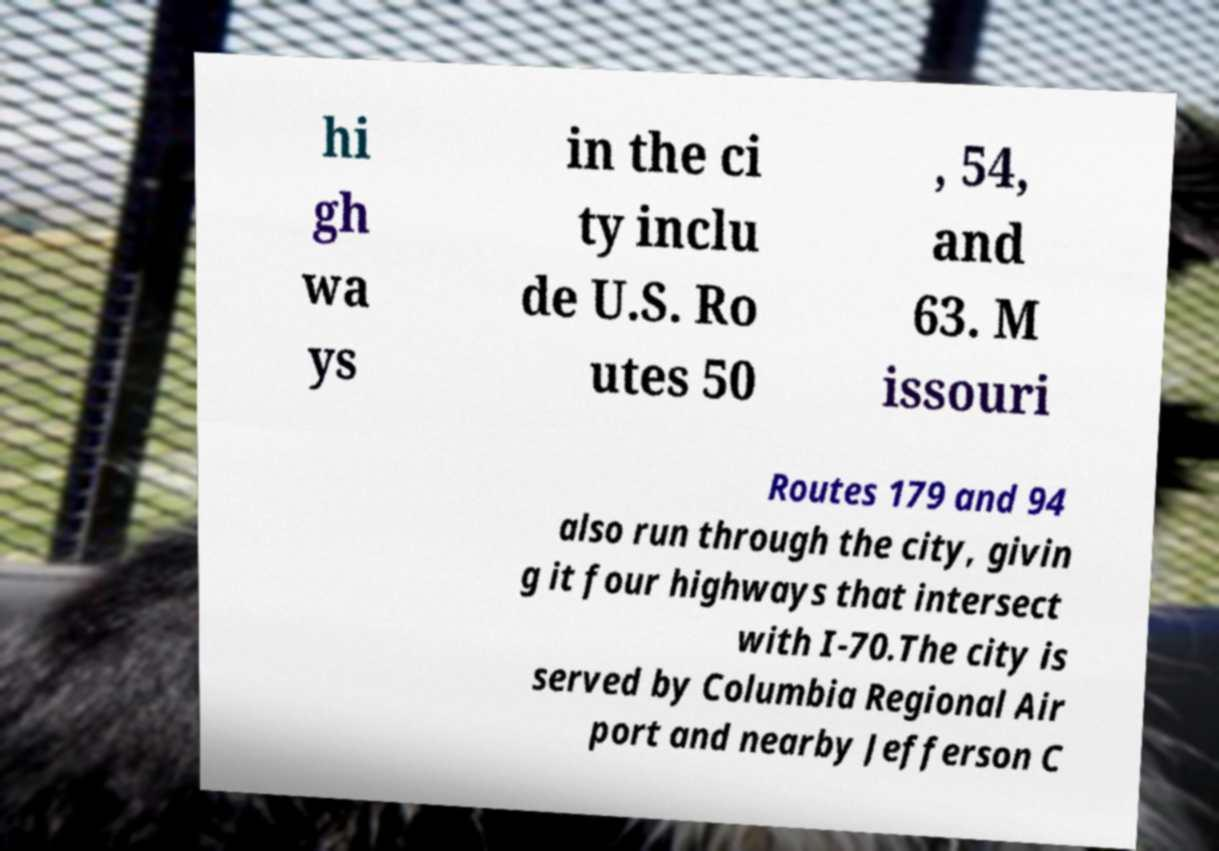Could you assist in decoding the text presented in this image and type it out clearly? hi gh wa ys in the ci ty inclu de U.S. Ro utes 50 , 54, and 63. M issouri Routes 179 and 94 also run through the city, givin g it four highways that intersect with I-70.The city is served by Columbia Regional Air port and nearby Jefferson C 